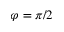<formula> <loc_0><loc_0><loc_500><loc_500>\varphi = \pi / 2</formula> 